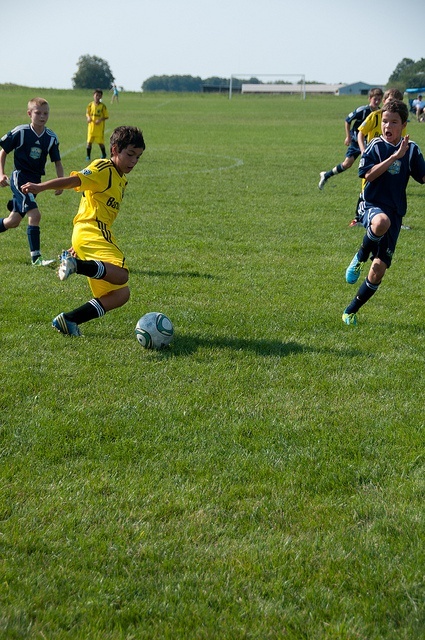Describe the objects in this image and their specific colors. I can see people in lightgray, black, and olive tones, people in lightgray, black, maroon, gray, and navy tones, people in lightgray, black, gray, and olive tones, people in lightgray, black, gray, maroon, and navy tones, and people in lightgray, olive, and black tones in this image. 